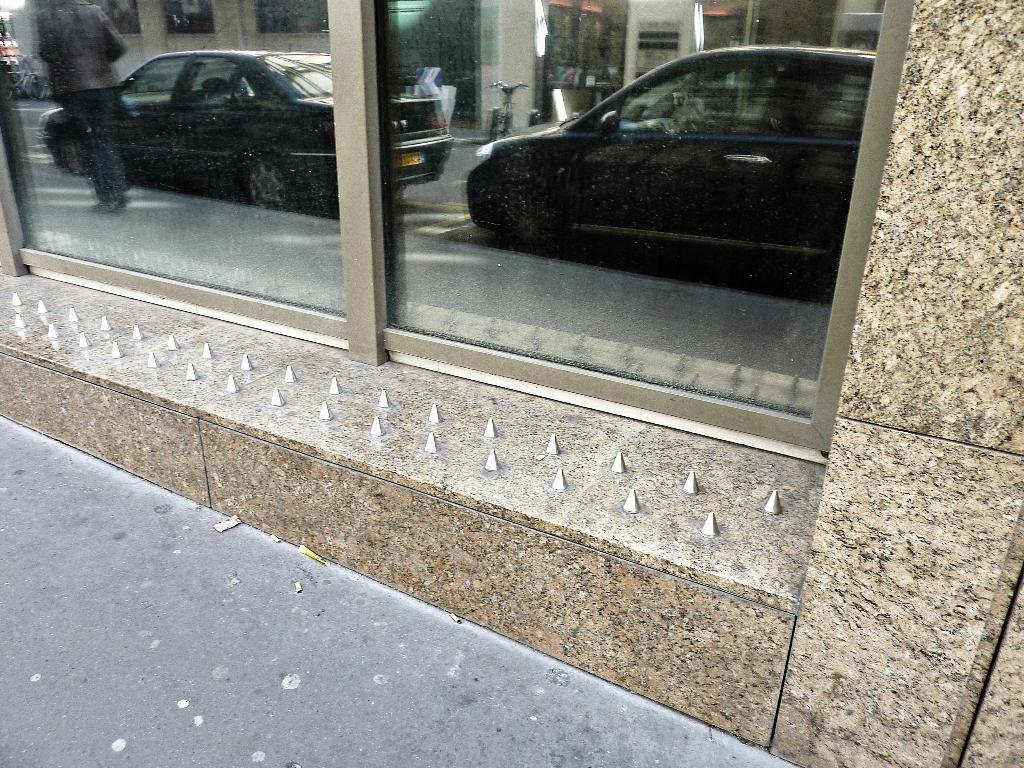What is located on the building in the image? There are glasses on a building in the image. What do the glasses reflect in the image? The glasses reflect vehicles, other buildings, and a person. How many objects are visible in the image? The image contains many objects. Where is the hydrant located in the image? There is no hydrant present in the image. What is the girl's name in the image? There is no girl present in the image. 